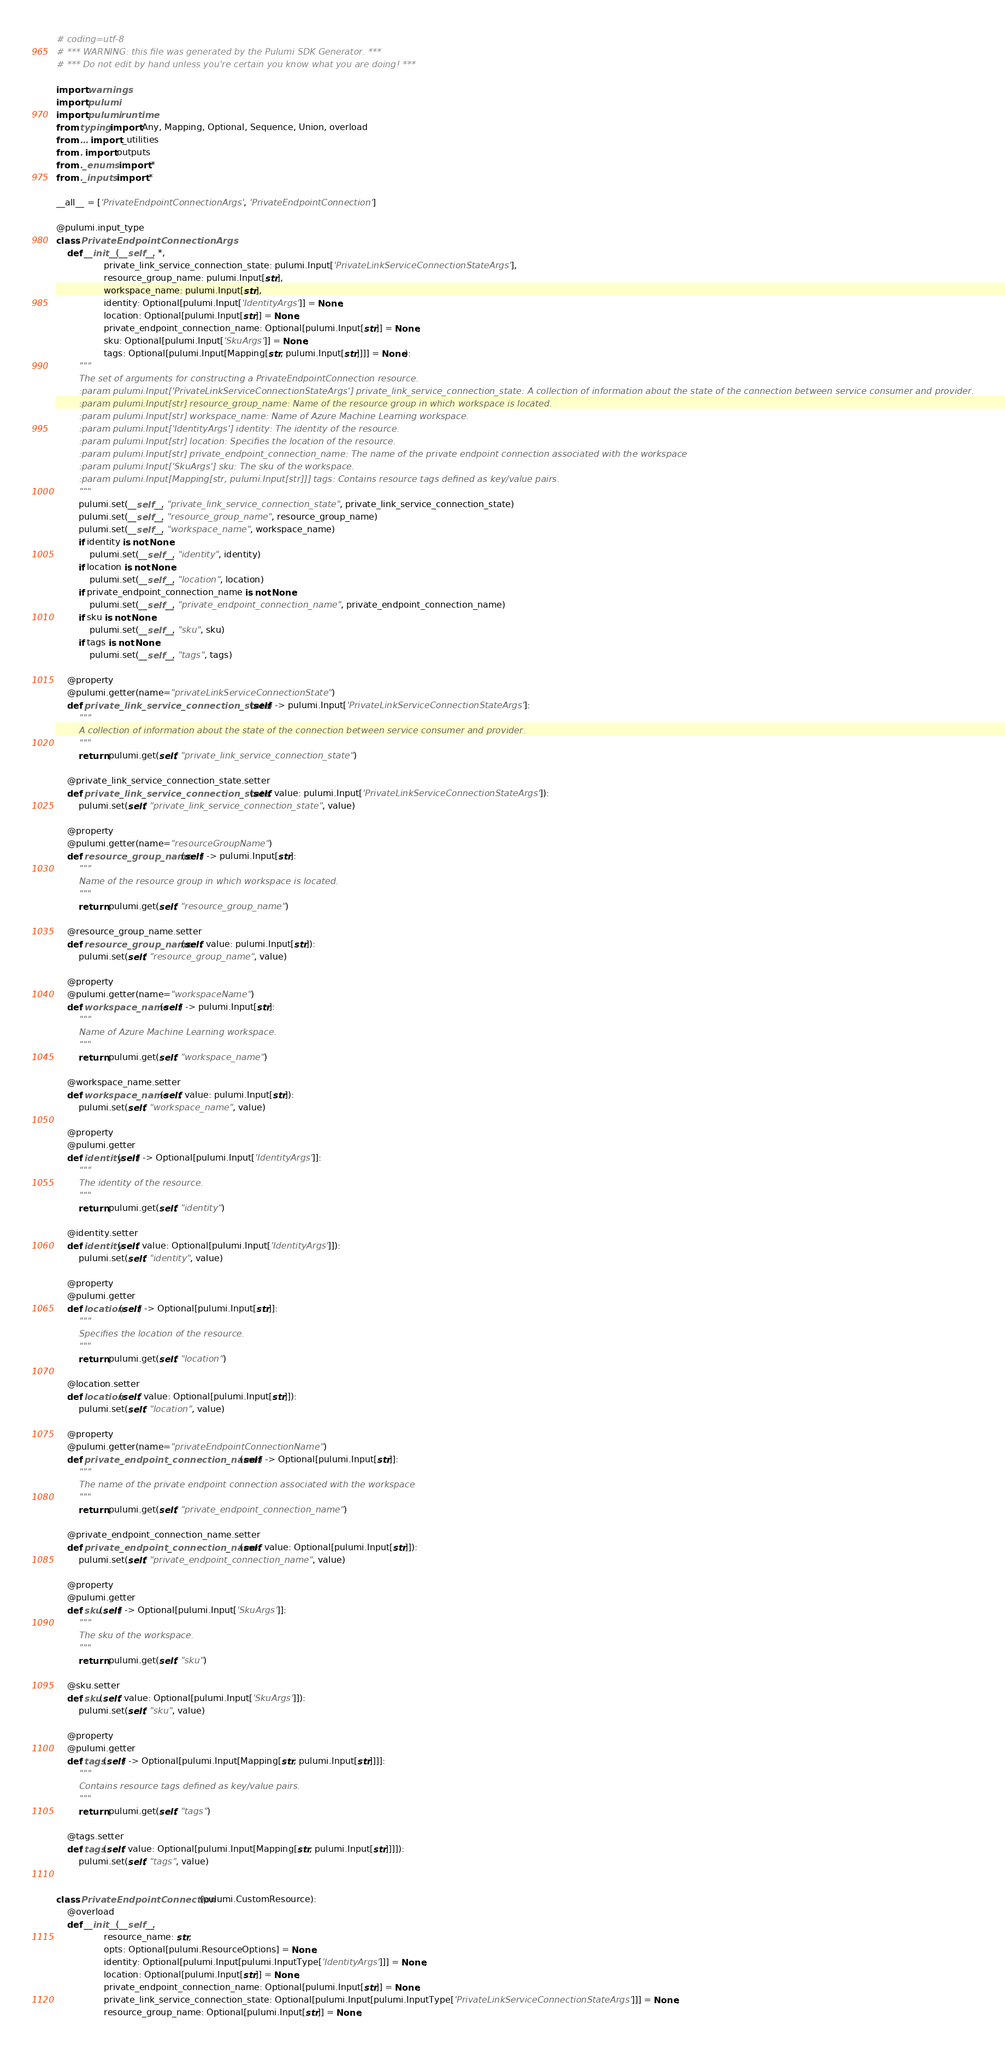Convert code to text. <code><loc_0><loc_0><loc_500><loc_500><_Python_># coding=utf-8
# *** WARNING: this file was generated by the Pulumi SDK Generator. ***
# *** Do not edit by hand unless you're certain you know what you are doing! ***

import warnings
import pulumi
import pulumi.runtime
from typing import Any, Mapping, Optional, Sequence, Union, overload
from ... import _utilities
from . import outputs
from ._enums import *
from ._inputs import *

__all__ = ['PrivateEndpointConnectionArgs', 'PrivateEndpointConnection']

@pulumi.input_type
class PrivateEndpointConnectionArgs:
    def __init__(__self__, *,
                 private_link_service_connection_state: pulumi.Input['PrivateLinkServiceConnectionStateArgs'],
                 resource_group_name: pulumi.Input[str],
                 workspace_name: pulumi.Input[str],
                 identity: Optional[pulumi.Input['IdentityArgs']] = None,
                 location: Optional[pulumi.Input[str]] = None,
                 private_endpoint_connection_name: Optional[pulumi.Input[str]] = None,
                 sku: Optional[pulumi.Input['SkuArgs']] = None,
                 tags: Optional[pulumi.Input[Mapping[str, pulumi.Input[str]]]] = None):
        """
        The set of arguments for constructing a PrivateEndpointConnection resource.
        :param pulumi.Input['PrivateLinkServiceConnectionStateArgs'] private_link_service_connection_state: A collection of information about the state of the connection between service consumer and provider.
        :param pulumi.Input[str] resource_group_name: Name of the resource group in which workspace is located.
        :param pulumi.Input[str] workspace_name: Name of Azure Machine Learning workspace.
        :param pulumi.Input['IdentityArgs'] identity: The identity of the resource.
        :param pulumi.Input[str] location: Specifies the location of the resource.
        :param pulumi.Input[str] private_endpoint_connection_name: The name of the private endpoint connection associated with the workspace
        :param pulumi.Input['SkuArgs'] sku: The sku of the workspace.
        :param pulumi.Input[Mapping[str, pulumi.Input[str]]] tags: Contains resource tags defined as key/value pairs.
        """
        pulumi.set(__self__, "private_link_service_connection_state", private_link_service_connection_state)
        pulumi.set(__self__, "resource_group_name", resource_group_name)
        pulumi.set(__self__, "workspace_name", workspace_name)
        if identity is not None:
            pulumi.set(__self__, "identity", identity)
        if location is not None:
            pulumi.set(__self__, "location", location)
        if private_endpoint_connection_name is not None:
            pulumi.set(__self__, "private_endpoint_connection_name", private_endpoint_connection_name)
        if sku is not None:
            pulumi.set(__self__, "sku", sku)
        if tags is not None:
            pulumi.set(__self__, "tags", tags)

    @property
    @pulumi.getter(name="privateLinkServiceConnectionState")
    def private_link_service_connection_state(self) -> pulumi.Input['PrivateLinkServiceConnectionStateArgs']:
        """
        A collection of information about the state of the connection between service consumer and provider.
        """
        return pulumi.get(self, "private_link_service_connection_state")

    @private_link_service_connection_state.setter
    def private_link_service_connection_state(self, value: pulumi.Input['PrivateLinkServiceConnectionStateArgs']):
        pulumi.set(self, "private_link_service_connection_state", value)

    @property
    @pulumi.getter(name="resourceGroupName")
    def resource_group_name(self) -> pulumi.Input[str]:
        """
        Name of the resource group in which workspace is located.
        """
        return pulumi.get(self, "resource_group_name")

    @resource_group_name.setter
    def resource_group_name(self, value: pulumi.Input[str]):
        pulumi.set(self, "resource_group_name", value)

    @property
    @pulumi.getter(name="workspaceName")
    def workspace_name(self) -> pulumi.Input[str]:
        """
        Name of Azure Machine Learning workspace.
        """
        return pulumi.get(self, "workspace_name")

    @workspace_name.setter
    def workspace_name(self, value: pulumi.Input[str]):
        pulumi.set(self, "workspace_name", value)

    @property
    @pulumi.getter
    def identity(self) -> Optional[pulumi.Input['IdentityArgs']]:
        """
        The identity of the resource.
        """
        return pulumi.get(self, "identity")

    @identity.setter
    def identity(self, value: Optional[pulumi.Input['IdentityArgs']]):
        pulumi.set(self, "identity", value)

    @property
    @pulumi.getter
    def location(self) -> Optional[pulumi.Input[str]]:
        """
        Specifies the location of the resource.
        """
        return pulumi.get(self, "location")

    @location.setter
    def location(self, value: Optional[pulumi.Input[str]]):
        pulumi.set(self, "location", value)

    @property
    @pulumi.getter(name="privateEndpointConnectionName")
    def private_endpoint_connection_name(self) -> Optional[pulumi.Input[str]]:
        """
        The name of the private endpoint connection associated with the workspace
        """
        return pulumi.get(self, "private_endpoint_connection_name")

    @private_endpoint_connection_name.setter
    def private_endpoint_connection_name(self, value: Optional[pulumi.Input[str]]):
        pulumi.set(self, "private_endpoint_connection_name", value)

    @property
    @pulumi.getter
    def sku(self) -> Optional[pulumi.Input['SkuArgs']]:
        """
        The sku of the workspace.
        """
        return pulumi.get(self, "sku")

    @sku.setter
    def sku(self, value: Optional[pulumi.Input['SkuArgs']]):
        pulumi.set(self, "sku", value)

    @property
    @pulumi.getter
    def tags(self) -> Optional[pulumi.Input[Mapping[str, pulumi.Input[str]]]]:
        """
        Contains resource tags defined as key/value pairs.
        """
        return pulumi.get(self, "tags")

    @tags.setter
    def tags(self, value: Optional[pulumi.Input[Mapping[str, pulumi.Input[str]]]]):
        pulumi.set(self, "tags", value)


class PrivateEndpointConnection(pulumi.CustomResource):
    @overload
    def __init__(__self__,
                 resource_name: str,
                 opts: Optional[pulumi.ResourceOptions] = None,
                 identity: Optional[pulumi.Input[pulumi.InputType['IdentityArgs']]] = None,
                 location: Optional[pulumi.Input[str]] = None,
                 private_endpoint_connection_name: Optional[pulumi.Input[str]] = None,
                 private_link_service_connection_state: Optional[pulumi.Input[pulumi.InputType['PrivateLinkServiceConnectionStateArgs']]] = None,
                 resource_group_name: Optional[pulumi.Input[str]] = None,</code> 